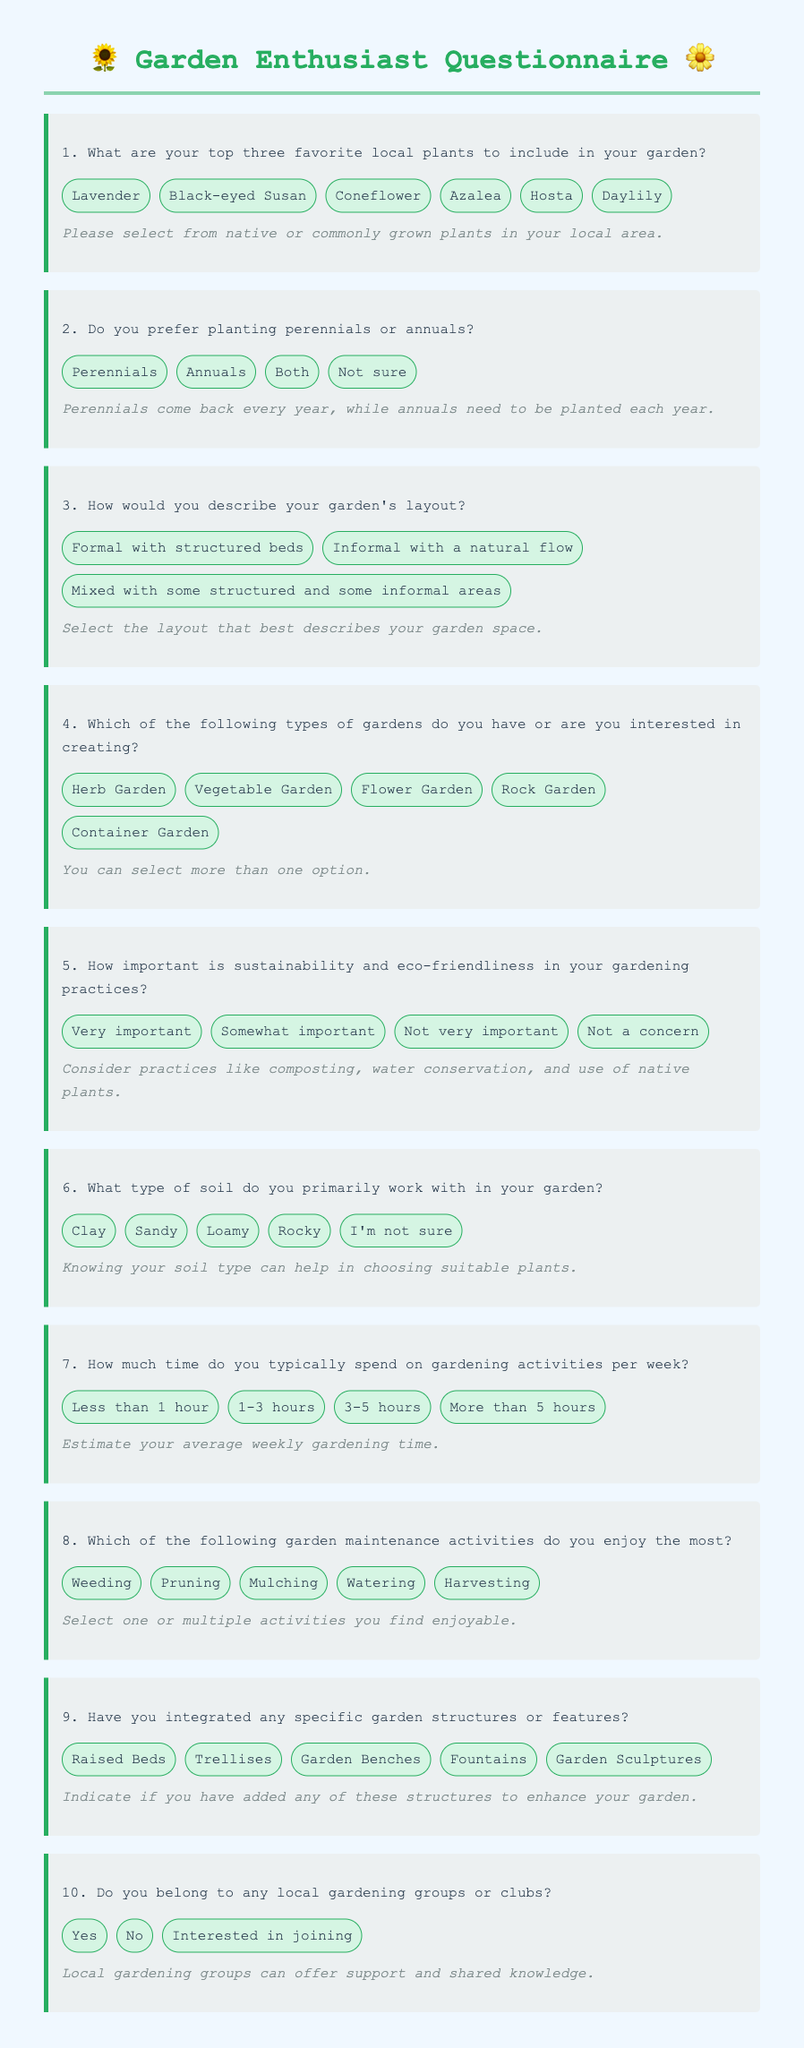What is the first question in the questionnaire? The first question asks about the respondent's favorite local plants to include in their garden.
Answer: What are your top three favorite local plants to include in your garden? How many options are provided for the plant preference question? There are six options provided for respondents to choose their favorite local plants.
Answer: Six What is the primary theme of this questionnaire? The questionnaire focuses on gathering information about gardening preferences and local plants.
Answer: Gardening preferences What type of garden is mentioned as an option in question four? The fourth question lists various types of gardens, one of which is an herb garden.
Answer: Herb Garden Which gardening practice is rated as 'Very important' in question five? Respondents can express their importance level regarding sustainability and eco-friendliness in gardening.
Answer: Sustainability How much time does the questionnaire allow respondents to indicate they spend on gardening activities per week? The question about time spent on gardening activities offers four specific ranges to choose from.
Answer: Four ranges What type of soil is included as an option in question six? The types of soil listed in the question include clay, sandy, loamy, rocky, and one other option.
Answer: Clay What kind of structures does question nine inquire about? The ninth question asks whether respondents have integrated specific garden structures and features.
Answer: Garden structures How many options can respondents choose in question four about garden types? The fourth question states that respondents can select more than one option regarding their garden interests.
Answer: More than one Does the questionnaire allow respondents to express interest in local gardening groups? Yes, the final question asks if respondents belong to any gardening groups or clubs.
Answer: Yes 